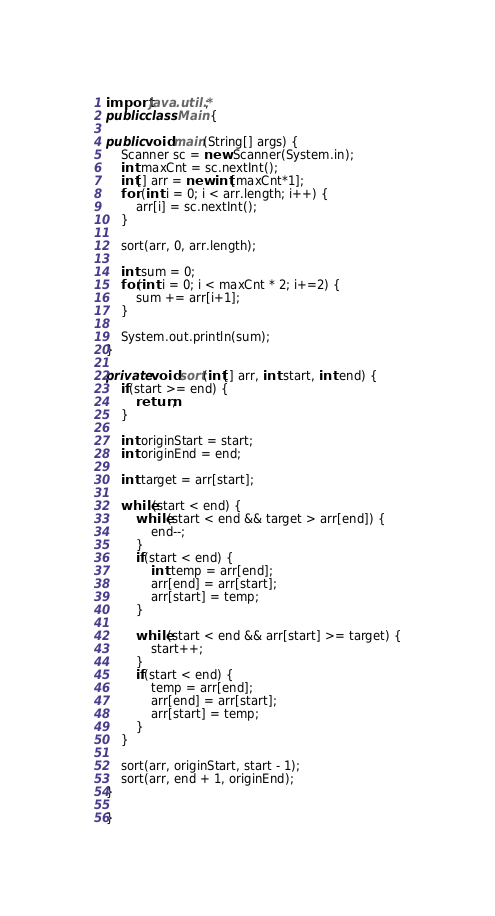Convert code to text. <code><loc_0><loc_0><loc_500><loc_500><_Java_>import java.util.*;
public class Main {

public void main(String[] args) {
	Scanner sc = new Scanner(System.in);
	int maxCnt = sc.nextInt();
	int[] arr = new int[maxCnt*1];
	for (int i = 0; i < arr.length; i++) {
		arr[i] = sc.nextInt();
	}

	sort(arr, 0, arr.length);

	int sum = 0;
	for(int i = 0; i < maxCnt * 2; i+=2) {
		sum += arr[i+1];
	} 

	System.out.println(sum);
}

private void sort(int[] arr, int start, int end) {
	if(start >= end) {
		return;
	}

	int originStart = start;
	int originEnd = end;

	int target = arr[start];

	while(start < end) {
		while(start < end && target > arr[end]) {
			end--;
		}
		if(start < end) {
			int temp = arr[end];
			arr[end] = arr[start];
			arr[start] = temp;
		}

		while(start < end && arr[start] >= target) {
			start++;
		}
		if(start < end) {
			temp = arr[end];
			arr[end] = arr[start];
			arr[start] = temp;
		}
	}

	sort(arr, originStart, start - 1);
	sort(arr, end + 1, originEnd);
}

}
</code> 